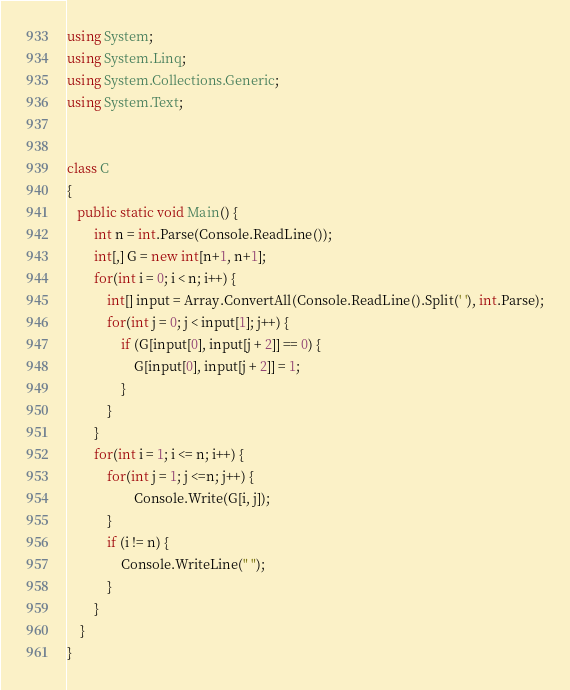Convert code to text. <code><loc_0><loc_0><loc_500><loc_500><_C#_>using System;
using System.Linq;
using System.Collections.Generic;
using System.Text;


class C
{
   public static void Main() {
        int n = int.Parse(Console.ReadLine());
        int[,] G = new int[n+1, n+1];
        for(int i = 0; i < n; i++) {
            int[] input = Array.ConvertAll(Console.ReadLine().Split(' '), int.Parse);
            for(int j = 0; j < input[1]; j++) {
                if (G[input[0], input[j + 2]] == 0) {
                    G[input[0], input[j + 2]] = 1;
                }
            }
        }
        for(int i = 1; i <= n; i++) {
            for(int j = 1; j <=n; j++) {
                    Console.Write(G[i, j]);
            }
            if (i != n) {
                Console.WriteLine(" ");
            }
        }
    }
}
</code> 